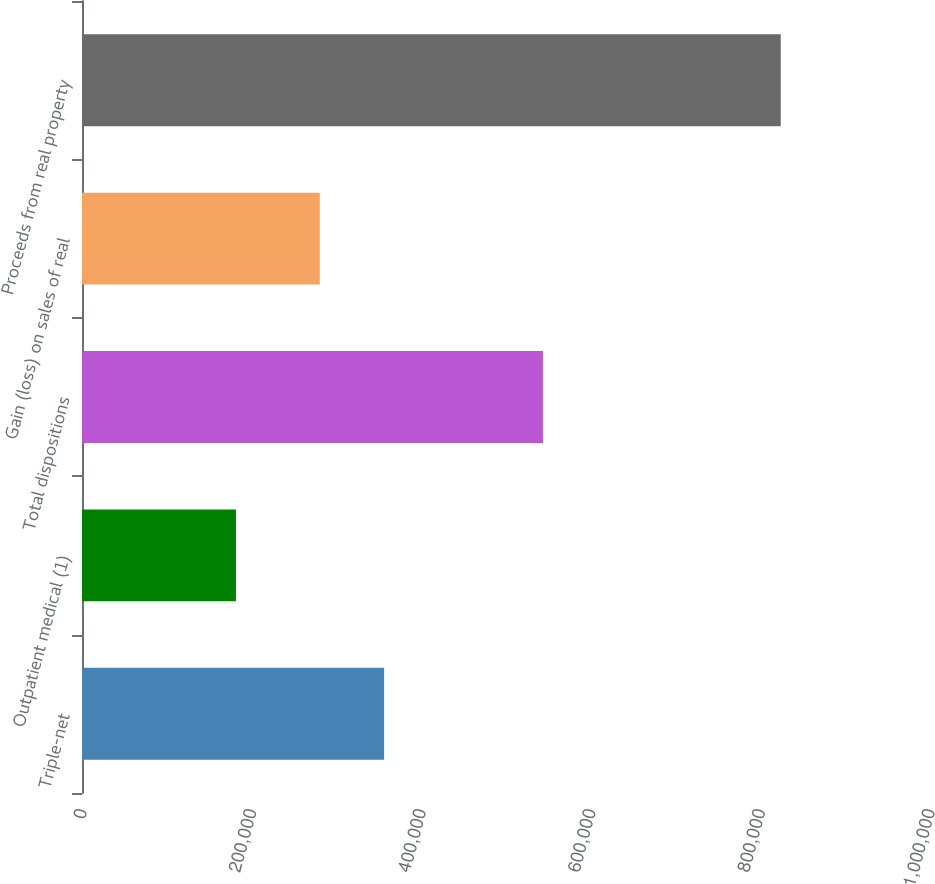Convert chart. <chart><loc_0><loc_0><loc_500><loc_500><bar_chart><fcel>Triple-net<fcel>Outpatient medical (1)<fcel>Total dispositions<fcel>Gain (loss) on sales of real<fcel>Proceeds from real property<nl><fcel>356300<fcel>181553<fcel>543577<fcel>280387<fcel>823964<nl></chart> 